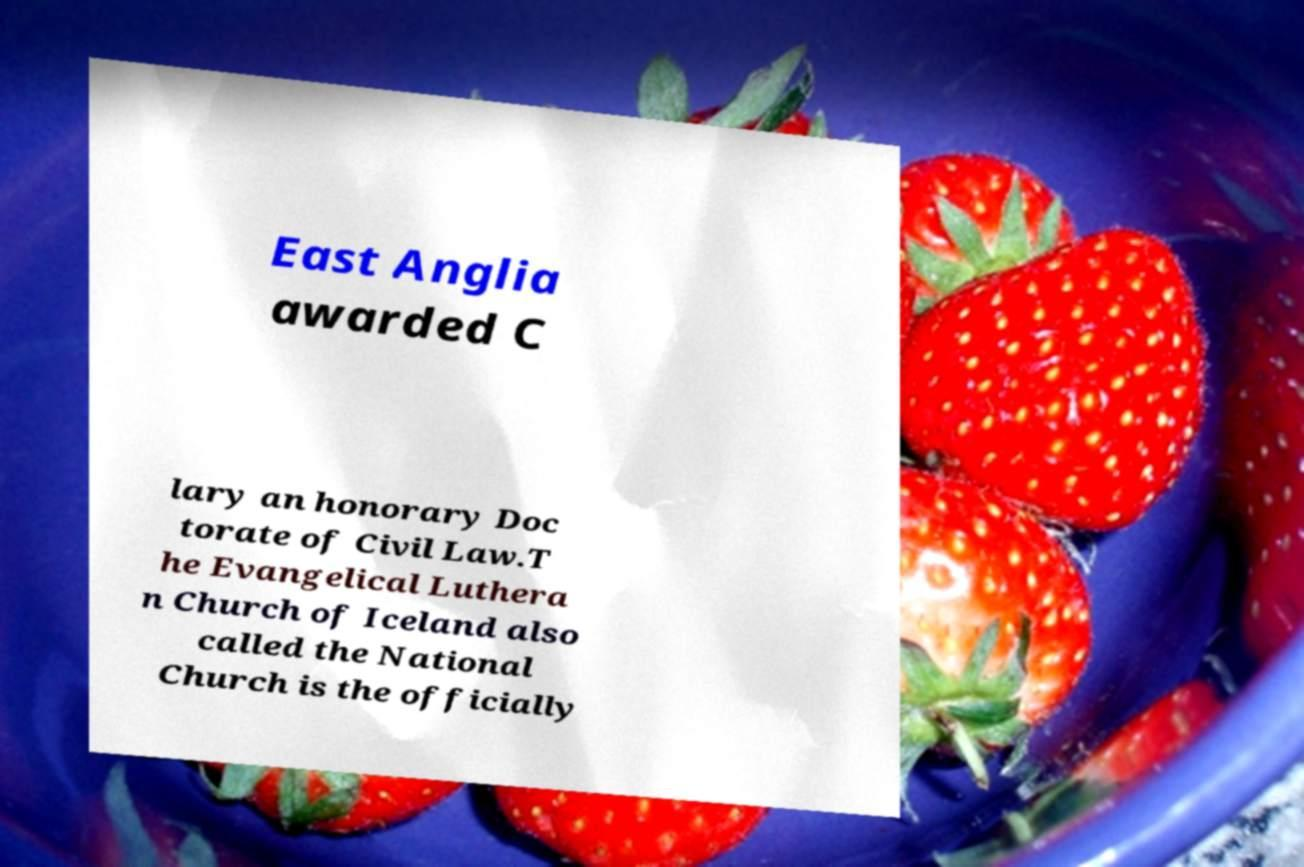Could you extract and type out the text from this image? East Anglia awarded C lary an honorary Doc torate of Civil Law.T he Evangelical Luthera n Church of Iceland also called the National Church is the officially 